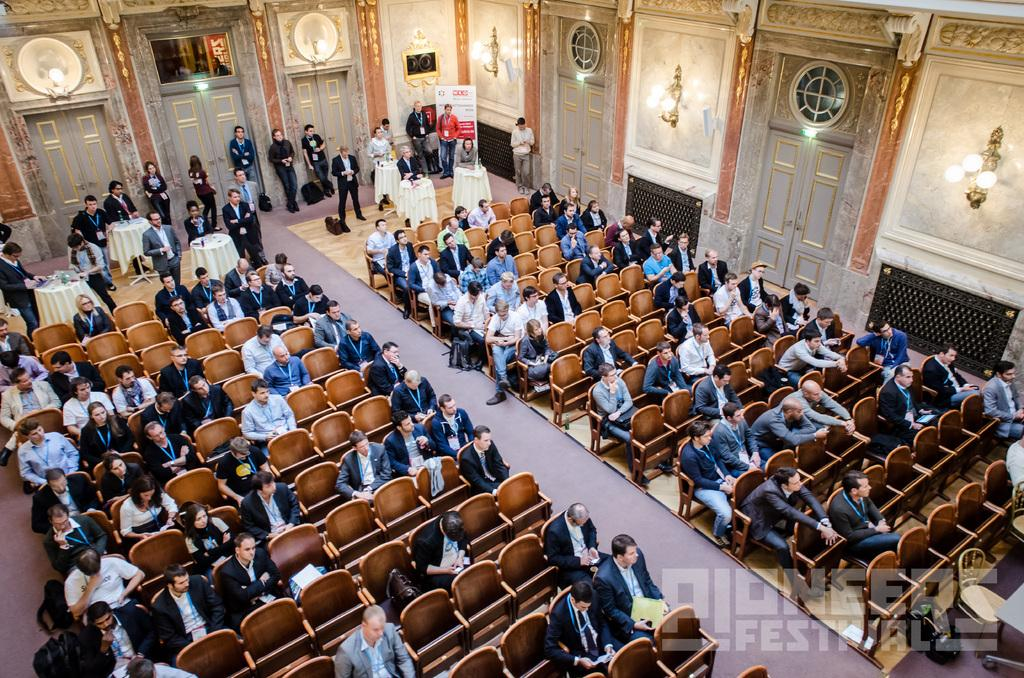What can be seen in the image involving multiple individuals? There are groups of people in the image. How are some of the people positioned in the image? Some people are sitting on chairs. What type of architectural feature is present in the image? There is a wall in the image. What is another feature that allows access to a different area? There is a door in the image. What can be seen providing illumination in the image? There are lights in the image. What additional element is present for decoration or information purposes? There is a banner in the image. What month is depicted on the banner in the image? There is no month mentioned on the banner in the image. How many people are smiling in the image? The provided facts do not mention the facial expressions of the people in the image. Are there any cherries visible in the image? There is no mention of cherries in the provided facts. 